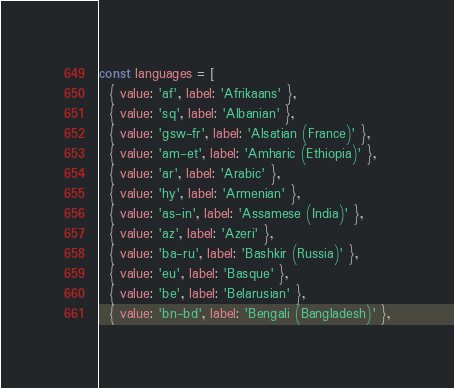Convert code to text. <code><loc_0><loc_0><loc_500><loc_500><_JavaScript_>const languages = [
  { value: 'af', label: 'Afrikaans' },
  { value: 'sq', label: 'Albanian' },
  { value: 'gsw-fr', label: 'Alsatian (France)' },
  { value: 'am-et', label: 'Amharic (Ethiopia)' },
  { value: 'ar', label: 'Arabic' },
  { value: 'hy', label: 'Armenian' },
  { value: 'as-in', label: 'Assamese (India)' },
  { value: 'az', label: 'Azeri' },
  { value: 'ba-ru', label: 'Bashkir (Russia)' },
  { value: 'eu', label: 'Basque' },
  { value: 'be', label: 'Belarusian' },
  { value: 'bn-bd', label: 'Bengali (Bangladesh)' },</code> 